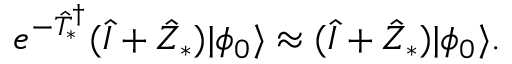<formula> <loc_0><loc_0><loc_500><loc_500>e ^ { - \hat { T } _ { * } ^ { \dagger } } ( \hat { I } + \hat { Z } _ { * } ) | \phi _ { 0 } \rangle \approx ( \hat { I } + \hat { Z } _ { * } ) | \phi _ { 0 } \rangle .</formula> 